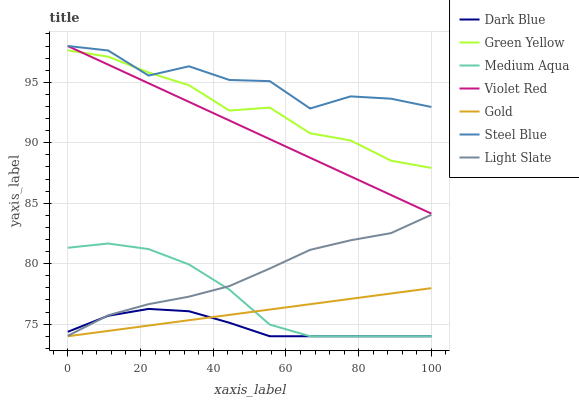Does Dark Blue have the minimum area under the curve?
Answer yes or no. Yes. Does Steel Blue have the maximum area under the curve?
Answer yes or no. Yes. Does Gold have the minimum area under the curve?
Answer yes or no. No. Does Gold have the maximum area under the curve?
Answer yes or no. No. Is Violet Red the smoothest?
Answer yes or no. Yes. Is Steel Blue the roughest?
Answer yes or no. Yes. Is Gold the smoothest?
Answer yes or no. No. Is Gold the roughest?
Answer yes or no. No. Does Light Slate have the lowest value?
Answer yes or no. No. Does Steel Blue have the highest value?
Answer yes or no. Yes. Does Gold have the highest value?
Answer yes or no. No. Is Medium Aqua less than Steel Blue?
Answer yes or no. Yes. Is Light Slate greater than Gold?
Answer yes or no. Yes. Does Gold intersect Medium Aqua?
Answer yes or no. Yes. Is Gold less than Medium Aqua?
Answer yes or no. No. Is Gold greater than Medium Aqua?
Answer yes or no. No. Does Medium Aqua intersect Steel Blue?
Answer yes or no. No. 